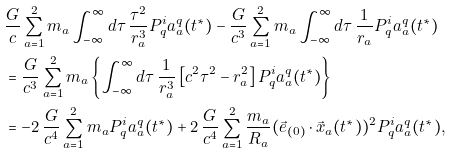<formula> <loc_0><loc_0><loc_500><loc_500>& \frac { G } { c } \sum _ { a = 1 } ^ { 2 } m _ { a } \int _ { - \infty } ^ { \infty } d \tau \, \frac { \tau ^ { 2 } } { r ^ { 3 } _ { a } } P ^ { i } _ { q } a ^ { q } _ { a } ( t ^ { \ast } ) - \frac { G } { c ^ { 3 } } \sum _ { a = 1 } ^ { 2 } m _ { a } \int _ { - \infty } ^ { \infty } d \tau \, \frac { 1 } { r _ { a } } P ^ { i } _ { q } a ^ { q } _ { a } ( t ^ { \ast } ) \\ & = \frac { G } { c ^ { 3 } } \sum _ { a = 1 } ^ { 2 } m _ { a } \left \{ \int _ { - \infty } ^ { \infty } d \tau \, \frac { 1 } { r ^ { 3 } _ { a } } \left [ c ^ { 2 } \tau ^ { 2 } - r ^ { 2 } _ { a } \right ] P ^ { i } _ { q } a ^ { q } _ { a } ( t ^ { \ast } ) \right \} \\ & = - 2 \, \frac { G } { c ^ { 4 } } \sum _ { a = 1 } ^ { 2 } m _ { a } P ^ { i } _ { q } a ^ { q } _ { a } ( t ^ { \ast } ) + 2 \, \frac { G } { c ^ { 4 } } \sum _ { a = 1 } ^ { 2 } \frac { m _ { a } } { R _ { a } } ( \vec { e } _ { ( 0 ) } \cdot \vec { x } _ { a } ( t ^ { \ast } ) ) ^ { 2 } P ^ { i } _ { q } a ^ { q } _ { a } ( t ^ { \ast } ) ,</formula> 